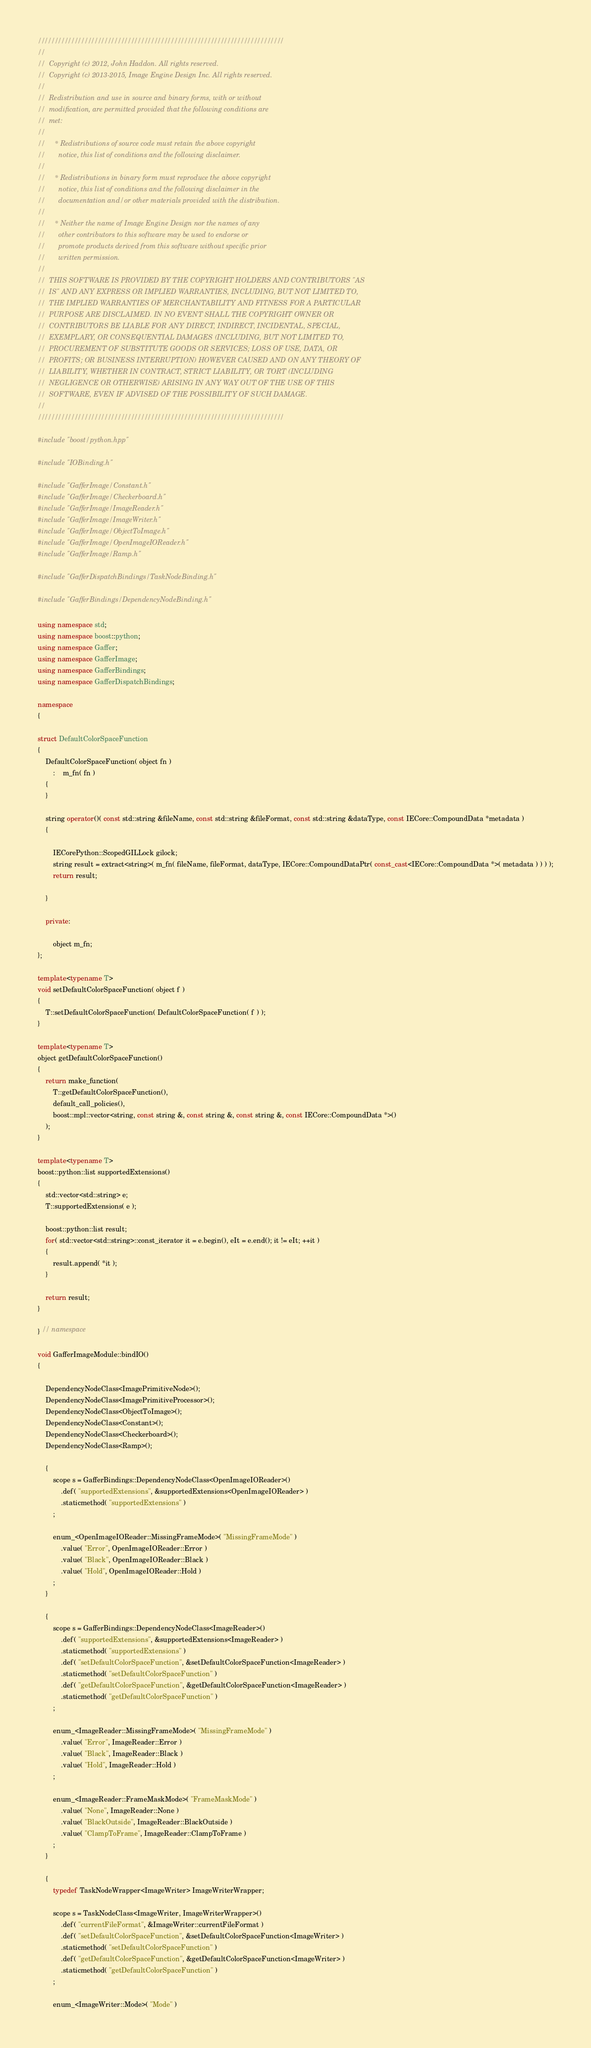Convert code to text. <code><loc_0><loc_0><loc_500><loc_500><_C++_>//////////////////////////////////////////////////////////////////////////
//
//  Copyright (c) 2012, John Haddon. All rights reserved.
//  Copyright (c) 2013-2015, Image Engine Design Inc. All rights reserved.
//
//  Redistribution and use in source and binary forms, with or without
//  modification, are permitted provided that the following conditions are
//  met:
//
//     * Redistributions of source code must retain the above copyright
//       notice, this list of conditions and the following disclaimer.
//
//     * Redistributions in binary form must reproduce the above copyright
//       notice, this list of conditions and the following disclaimer in the
//       documentation and/or other materials provided with the distribution.
//
//     * Neither the name of Image Engine Design nor the names of any
//       other contributors to this software may be used to endorse or
//       promote products derived from this software without specific prior
//       written permission.
//
//  THIS SOFTWARE IS PROVIDED BY THE COPYRIGHT HOLDERS AND CONTRIBUTORS "AS
//  IS" AND ANY EXPRESS OR IMPLIED WARRANTIES, INCLUDING, BUT NOT LIMITED TO,
//  THE IMPLIED WARRANTIES OF MERCHANTABILITY AND FITNESS FOR A PARTICULAR
//  PURPOSE ARE DISCLAIMED. IN NO EVENT SHALL THE COPYRIGHT OWNER OR
//  CONTRIBUTORS BE LIABLE FOR ANY DIRECT, INDIRECT, INCIDENTAL, SPECIAL,
//  EXEMPLARY, OR CONSEQUENTIAL DAMAGES (INCLUDING, BUT NOT LIMITED TO,
//  PROCUREMENT OF SUBSTITUTE GOODS OR SERVICES; LOSS OF USE, DATA, OR
//  PROFITS; OR BUSINESS INTERRUPTION) HOWEVER CAUSED AND ON ANY THEORY OF
//  LIABILITY, WHETHER IN CONTRACT, STRICT LIABILITY, OR TORT (INCLUDING
//  NEGLIGENCE OR OTHERWISE) ARISING IN ANY WAY OUT OF THE USE OF THIS
//  SOFTWARE, EVEN IF ADVISED OF THE POSSIBILITY OF SUCH DAMAGE.
//
//////////////////////////////////////////////////////////////////////////

#include "boost/python.hpp"

#include "IOBinding.h"

#include "GafferImage/Constant.h"
#include "GafferImage/Checkerboard.h"
#include "GafferImage/ImageReader.h"
#include "GafferImage/ImageWriter.h"
#include "GafferImage/ObjectToImage.h"
#include "GafferImage/OpenImageIOReader.h"
#include "GafferImage/Ramp.h"

#include "GafferDispatchBindings/TaskNodeBinding.h"

#include "GafferBindings/DependencyNodeBinding.h"

using namespace std;
using namespace boost::python;
using namespace Gaffer;
using namespace GafferImage;
using namespace GafferBindings;
using namespace GafferDispatchBindings;

namespace
{

struct DefaultColorSpaceFunction
{
	DefaultColorSpaceFunction( object fn )
		:	m_fn( fn )
	{
	}

	string operator()( const std::string &fileName, const std::string &fileFormat, const std::string &dataType, const IECore::CompoundData *metadata )
	{

		IECorePython::ScopedGILLock gilock;
		string result = extract<string>( m_fn( fileName, fileFormat, dataType, IECore::CompoundDataPtr( const_cast<IECore::CompoundData *>( metadata ) ) ) );
		return result;

	}

	private:

		object m_fn;
};

template<typename T>
void setDefaultColorSpaceFunction( object f )
{
	T::setDefaultColorSpaceFunction( DefaultColorSpaceFunction( f ) );
}

template<typename T>
object getDefaultColorSpaceFunction()
{
	return make_function(
		T::getDefaultColorSpaceFunction(),
		default_call_policies(),
		boost::mpl::vector<string, const string &, const string &, const string &, const IECore::CompoundData *>()
	);
}

template<typename T>
boost::python::list supportedExtensions()
{
	std::vector<std::string> e;
	T::supportedExtensions( e );

	boost::python::list result;
	for( std::vector<std::string>::const_iterator it = e.begin(), eIt = e.end(); it != eIt; ++it )
	{
		result.append( *it );
	}

	return result;
}

} // namespace

void GafferImageModule::bindIO()
{

	DependencyNodeClass<ImagePrimitiveNode>();
	DependencyNodeClass<ImagePrimitiveProcessor>();
	DependencyNodeClass<ObjectToImage>();
	DependencyNodeClass<Constant>();
	DependencyNodeClass<Checkerboard>();
	DependencyNodeClass<Ramp>();

	{
		scope s = GafferBindings::DependencyNodeClass<OpenImageIOReader>()
			.def( "supportedExtensions", &supportedExtensions<OpenImageIOReader> )
			.staticmethod( "supportedExtensions" )
		;

		enum_<OpenImageIOReader::MissingFrameMode>( "MissingFrameMode" )
			.value( "Error", OpenImageIOReader::Error )
			.value( "Black", OpenImageIOReader::Black )
			.value( "Hold", OpenImageIOReader::Hold )
		;
	}

	{
		scope s = GafferBindings::DependencyNodeClass<ImageReader>()
			.def( "supportedExtensions", &supportedExtensions<ImageReader> )
			.staticmethod( "supportedExtensions" )
			.def( "setDefaultColorSpaceFunction", &setDefaultColorSpaceFunction<ImageReader> )
			.staticmethod( "setDefaultColorSpaceFunction" )
			.def( "getDefaultColorSpaceFunction", &getDefaultColorSpaceFunction<ImageReader> )
			.staticmethod( "getDefaultColorSpaceFunction" )
		;

		enum_<ImageReader::MissingFrameMode>( "MissingFrameMode" )
			.value( "Error", ImageReader::Error )
			.value( "Black", ImageReader::Black )
			.value( "Hold", ImageReader::Hold )
		;

		enum_<ImageReader::FrameMaskMode>( "FrameMaskMode" )
			.value( "None", ImageReader::None )
			.value( "BlackOutside", ImageReader::BlackOutside )
			.value( "ClampToFrame", ImageReader::ClampToFrame )
		;
	}

	{
		typedef TaskNodeWrapper<ImageWriter> ImageWriterWrapper;

		scope s = TaskNodeClass<ImageWriter, ImageWriterWrapper>()
			.def( "currentFileFormat", &ImageWriter::currentFileFormat )
			.def( "setDefaultColorSpaceFunction", &setDefaultColorSpaceFunction<ImageWriter> )
			.staticmethod( "setDefaultColorSpaceFunction" )
			.def( "getDefaultColorSpaceFunction", &getDefaultColorSpaceFunction<ImageWriter> )
			.staticmethod( "getDefaultColorSpaceFunction" )
		;

		enum_<ImageWriter::Mode>( "Mode" )</code> 